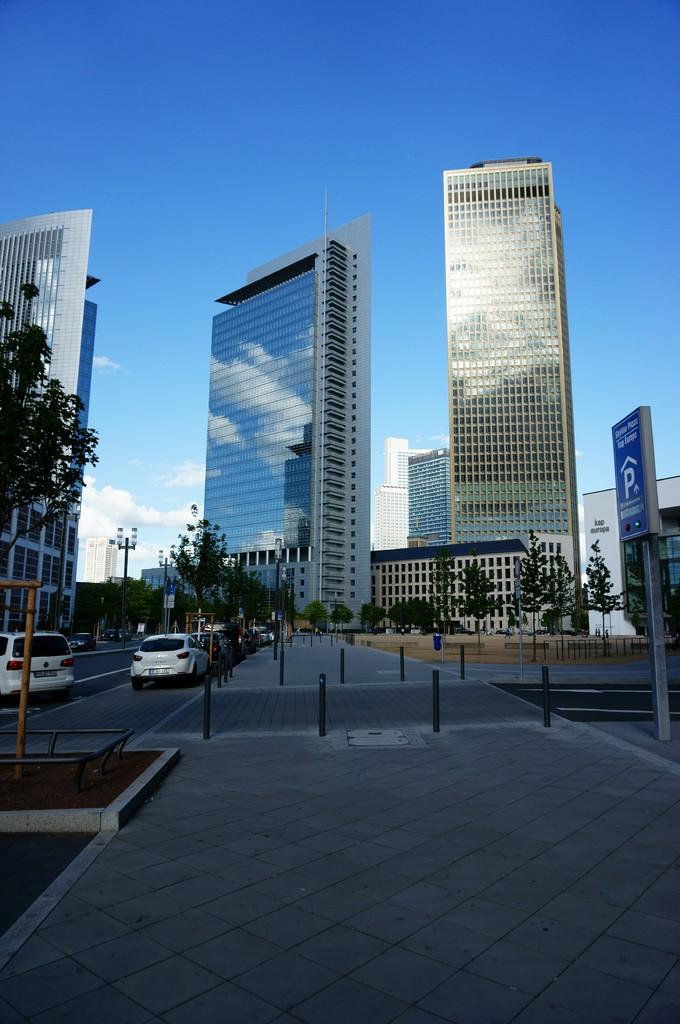What is the main feature of the image? There is a road in the image. What can be seen traveling on the road? There are cars in the image. What type of natural elements are present in the image? There are trees in the image. What type of man-made structures are present in the image? There are buildings in the image. What is located on the right side of the image? There is a sign board on the right side of the image. How would you describe the weather in the image? The sky is blue with clouds, suggesting a partly cloudy day. How many teeth can be seen on the toothbrush in the image? There is no toothbrush present in the image. What type of jellyfish can be seen swimming in the sky? There are no jellyfish present in the image, and jellyfish cannot swim in the sky. 